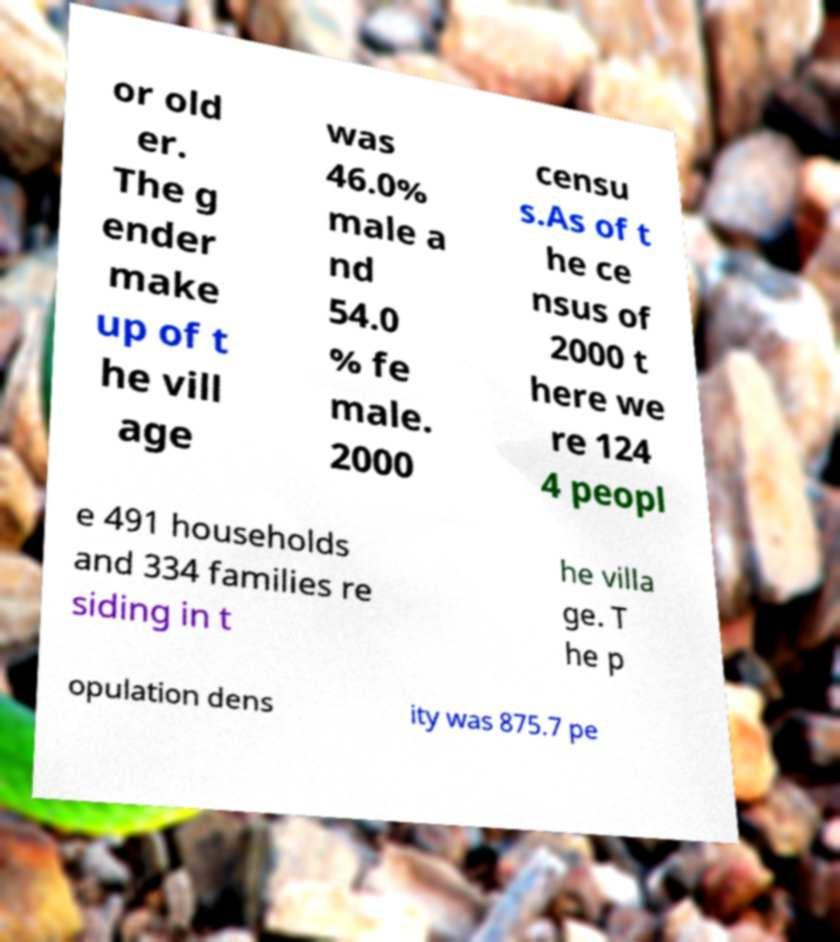Could you extract and type out the text from this image? or old er. The g ender make up of t he vill age was 46.0% male a nd 54.0 % fe male. 2000 censu s.As of t he ce nsus of 2000 t here we re 124 4 peopl e 491 households and 334 families re siding in t he villa ge. T he p opulation dens ity was 875.7 pe 